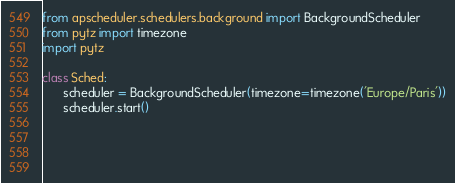<code> <loc_0><loc_0><loc_500><loc_500><_Python_>from apscheduler.schedulers.background import BackgroundScheduler
from pytz import timezone
import pytz

class Sched:
      scheduler = BackgroundScheduler(timezone=timezone('Europe/Paris'))
      scheduler.start()
      
      

      
</code> 